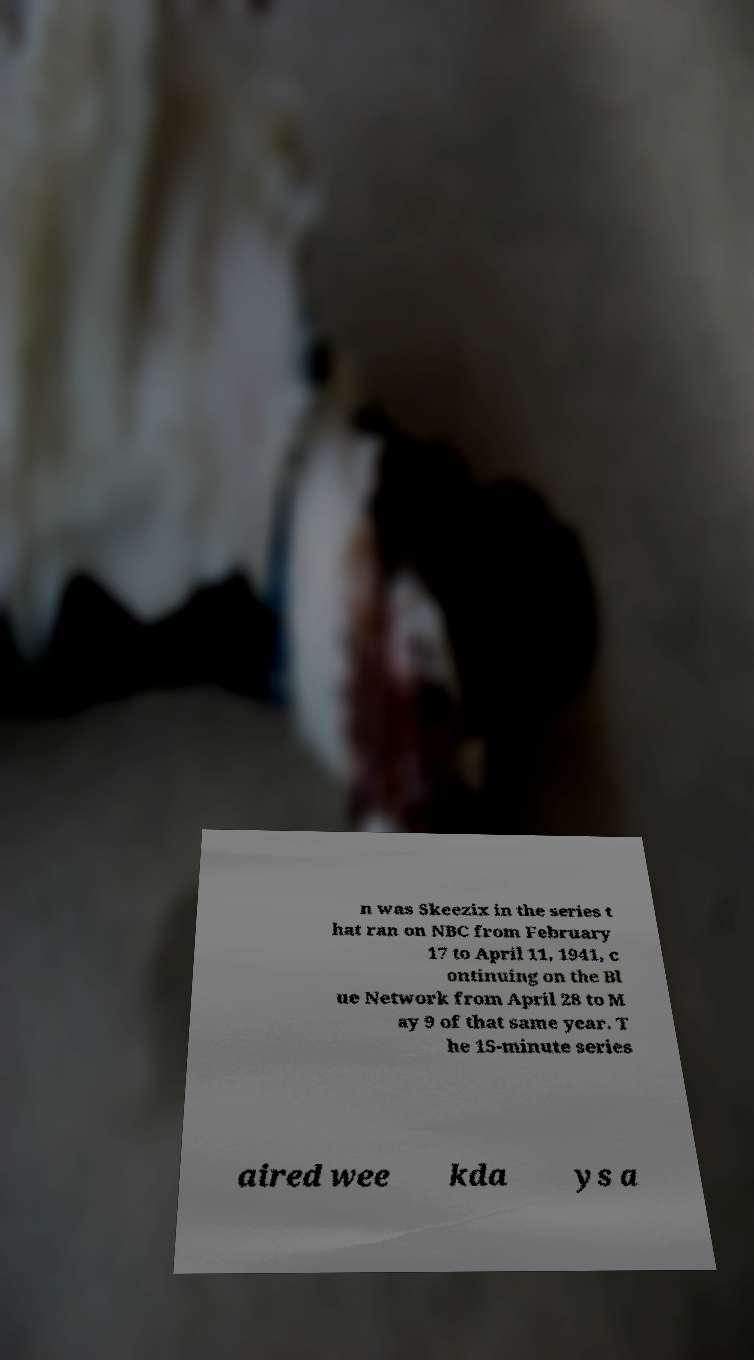I need the written content from this picture converted into text. Can you do that? n was Skeezix in the series t hat ran on NBC from February 17 to April 11, 1941, c ontinuing on the Bl ue Network from April 28 to M ay 9 of that same year. T he 15-minute series aired wee kda ys a 